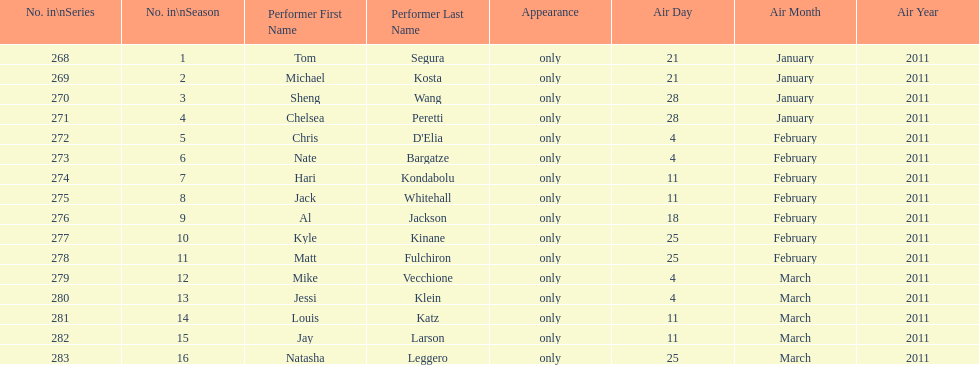Which month had the most performers? February. Parse the table in full. {'header': ['No. in\\nSeries', 'No. in\\nSeason', 'Performer First Name', 'Performer Last Name', 'Appearance', 'Air Day', 'Air Month', 'Air Year'], 'rows': [['268', '1', 'Tom', 'Segura', 'only', '21', 'January', '2011'], ['269', '2', 'Michael', 'Kosta', 'only', '21', 'January', '2011'], ['270', '3', 'Sheng', 'Wang', 'only', '28', 'January', '2011'], ['271', '4', 'Chelsea', 'Peretti', 'only', '28', 'January', '2011'], ['272', '5', 'Chris', "D'Elia", 'only', '4', 'February', '2011'], ['273', '6', 'Nate', 'Bargatze', 'only', '4', 'February', '2011'], ['274', '7', 'Hari', 'Kondabolu', 'only', '11', 'February', '2011'], ['275', '8', 'Jack', 'Whitehall', 'only', '11', 'February', '2011'], ['276', '9', 'Al', 'Jackson', 'only', '18', 'February', '2011'], ['277', '10', 'Kyle', 'Kinane', 'only', '25', 'February', '2011'], ['278', '11', 'Matt', 'Fulchiron', 'only', '25', 'February', '2011'], ['279', '12', 'Mike', 'Vecchione', 'only', '4', 'March', '2011'], ['280', '13', 'Jessi', 'Klein', 'only', '4', 'March', '2011'], ['281', '14', 'Louis', 'Katz', 'only', '11', 'March', '2011'], ['282', '15', 'Jay', 'Larson', 'only', '11', 'March', '2011'], ['283', '16', 'Natasha', 'Leggero', 'only', '25', 'March', '2011']]} 